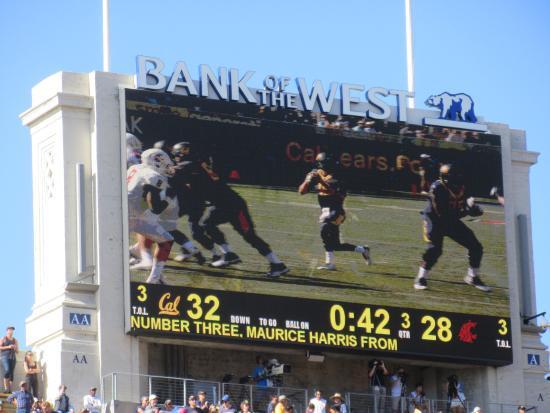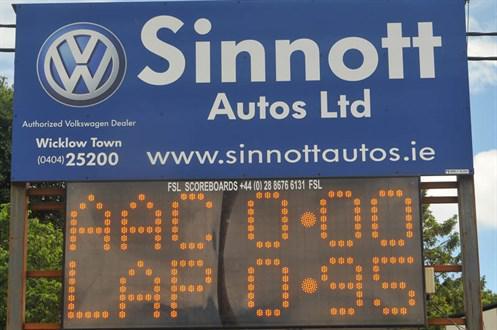The first image is the image on the left, the second image is the image on the right. Considering the images on both sides, is "The left image features a rectangular sign containing a screen that displays a sporting event." valid? Answer yes or no. Yes. The first image is the image on the left, the second image is the image on the right. Given the left and right images, does the statement "The sport being played in the left image was invented in the United States." hold true? Answer yes or no. Yes. 